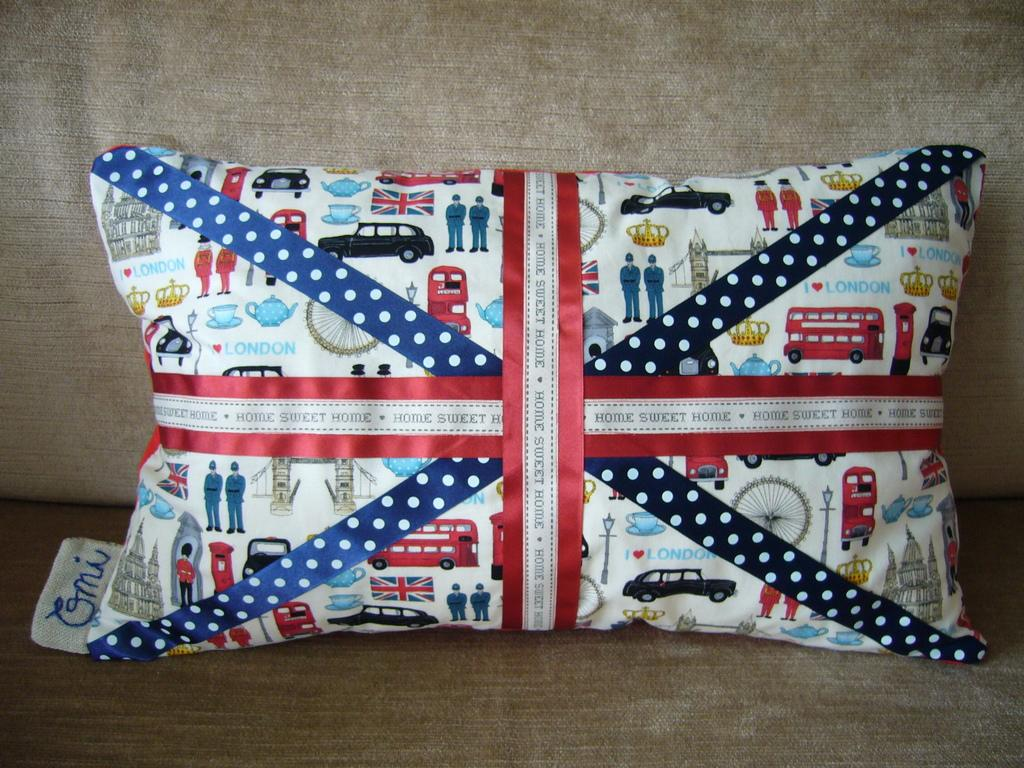What is present in the image that is wrapped or packaged? There is a packet in the image. How is the packet decorated or tied? The packet is tied with violet and red color ribbons. Where is the packet located in the image? The packet is on a sofa. What is the color of the background in the image? The background of the image is gray in color. What thoughts are expressed by the toes in the image? There are no toes present in the image, as it only features a packet tied with ribbons and placed on a sofa against a gray background. 